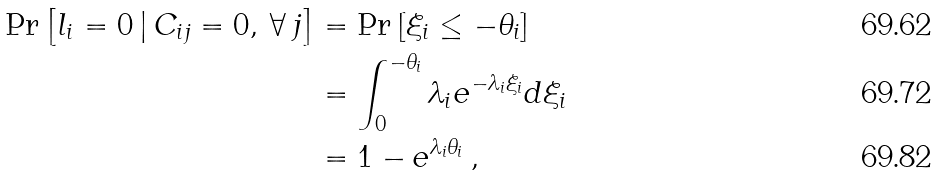<formula> <loc_0><loc_0><loc_500><loc_500>\Pr \left [ l _ { i } = 0 \, | \, C _ { i j } = 0 , \, \forall \, j \right ] & = \Pr \left [ \xi _ { i } \leq - \theta _ { i } \right ] \\ & = \int _ { 0 } ^ { - \theta _ { i } } { \lambda _ { i } e ^ { - \lambda _ { i } \xi _ { i } } d \xi _ { i } } \\ & = 1 - e ^ { \lambda _ { i } \theta _ { i } } \, ,</formula> 